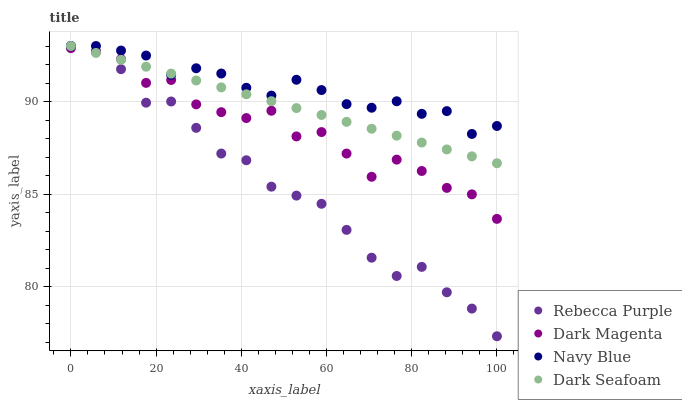Does Rebecca Purple have the minimum area under the curve?
Answer yes or no. Yes. Does Navy Blue have the maximum area under the curve?
Answer yes or no. Yes. Does Dark Seafoam have the minimum area under the curve?
Answer yes or no. No. Does Dark Seafoam have the maximum area under the curve?
Answer yes or no. No. Is Dark Seafoam the smoothest?
Answer yes or no. Yes. Is Dark Magenta the roughest?
Answer yes or no. Yes. Is Rebecca Purple the smoothest?
Answer yes or no. No. Is Rebecca Purple the roughest?
Answer yes or no. No. Does Rebecca Purple have the lowest value?
Answer yes or no. Yes. Does Dark Seafoam have the lowest value?
Answer yes or no. No. Does Rebecca Purple have the highest value?
Answer yes or no. Yes. Does Dark Magenta have the highest value?
Answer yes or no. No. Is Dark Magenta less than Navy Blue?
Answer yes or no. Yes. Is Navy Blue greater than Dark Magenta?
Answer yes or no. Yes. Does Rebecca Purple intersect Dark Magenta?
Answer yes or no. Yes. Is Rebecca Purple less than Dark Magenta?
Answer yes or no. No. Is Rebecca Purple greater than Dark Magenta?
Answer yes or no. No. Does Dark Magenta intersect Navy Blue?
Answer yes or no. No. 